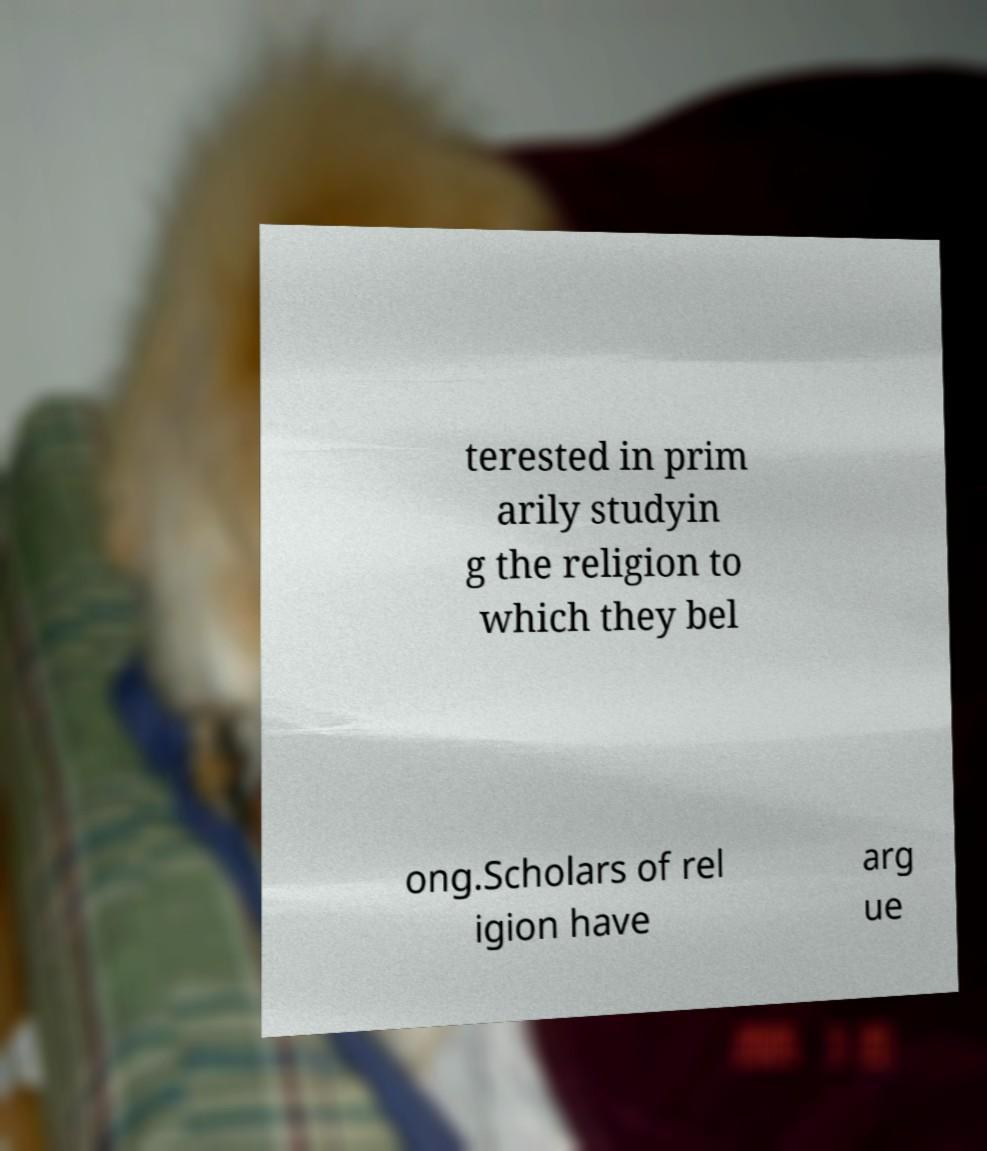Can you read and provide the text displayed in the image?This photo seems to have some interesting text. Can you extract and type it out for me? terested in prim arily studyin g the religion to which they bel ong.Scholars of rel igion have arg ue 